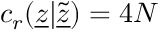Convert formula to latex. <formula><loc_0><loc_0><loc_500><loc_500>c _ { r } ( \underline { z } | \tilde { \underline { z } } ) = 4 N</formula> 